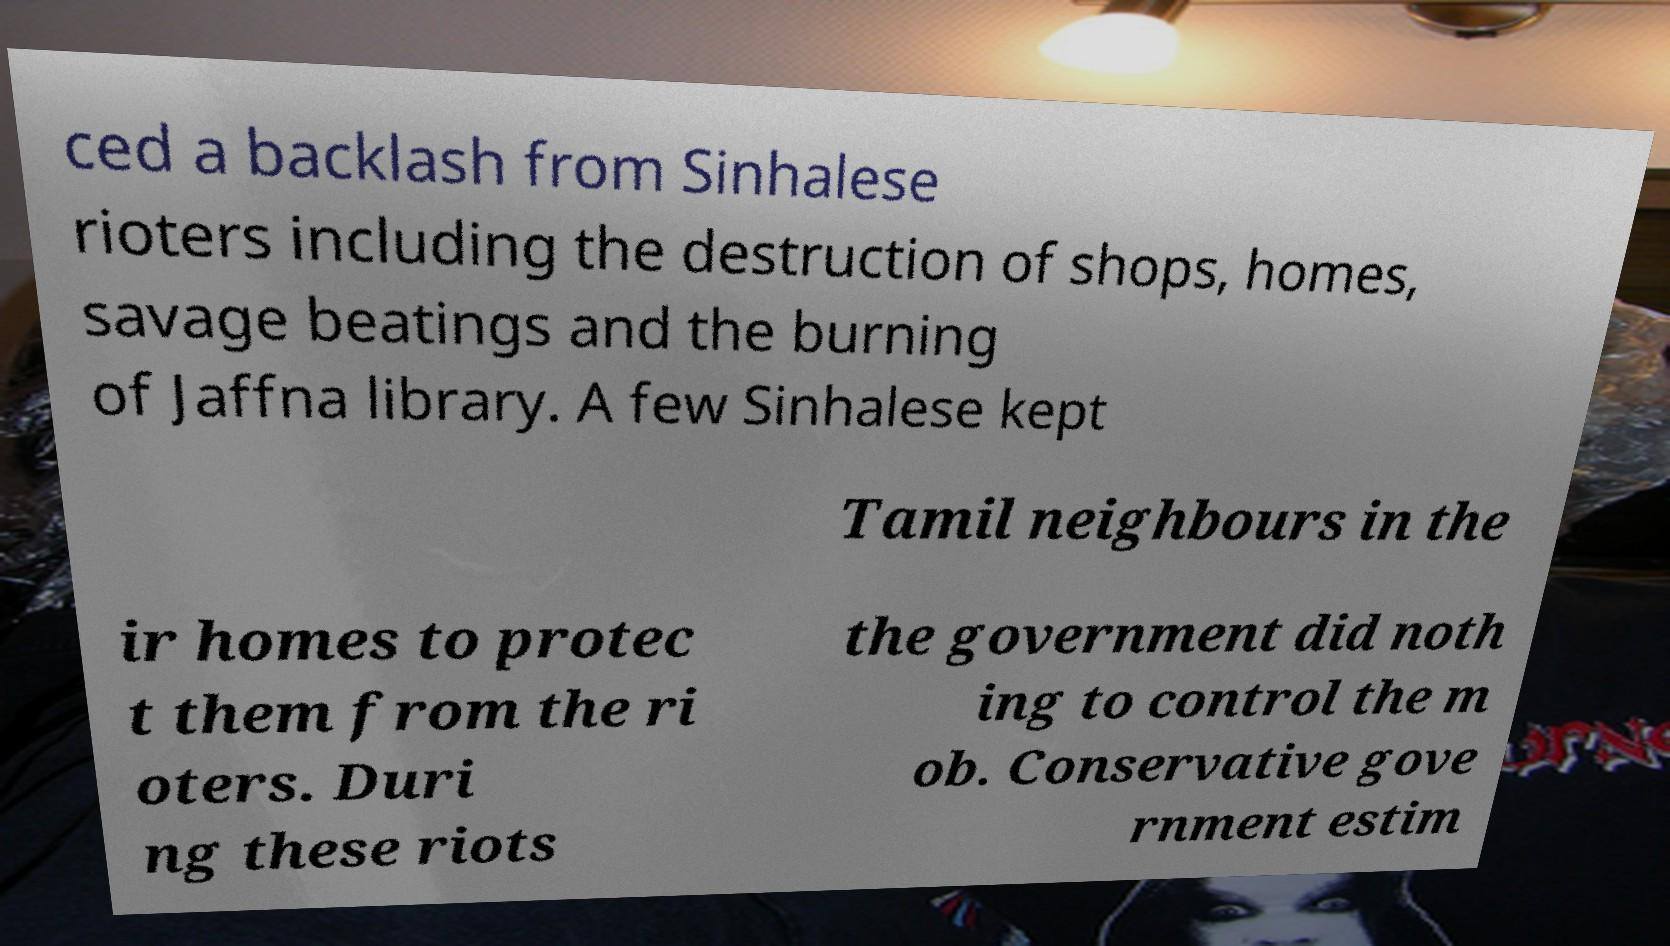Can you read and provide the text displayed in the image?This photo seems to have some interesting text. Can you extract and type it out for me? ced a backlash from Sinhalese rioters including the destruction of shops, homes, savage beatings and the burning of Jaffna library. A few Sinhalese kept Tamil neighbours in the ir homes to protec t them from the ri oters. Duri ng these riots the government did noth ing to control the m ob. Conservative gove rnment estim 